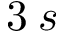Convert formula to latex. <formula><loc_0><loc_0><loc_500><loc_500>3 \, s</formula> 